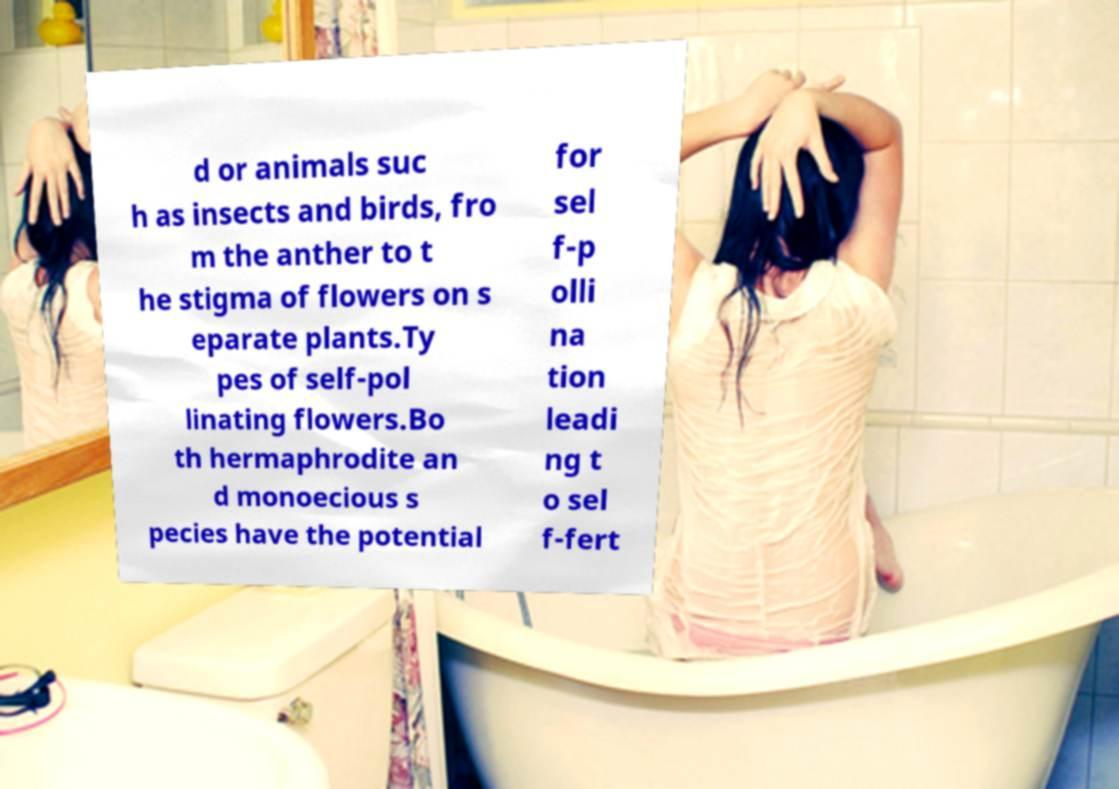Could you extract and type out the text from this image? d or animals suc h as insects and birds, fro m the anther to t he stigma of flowers on s eparate plants.Ty pes of self-pol linating flowers.Bo th hermaphrodite an d monoecious s pecies have the potential for sel f-p olli na tion leadi ng t o sel f-fert 